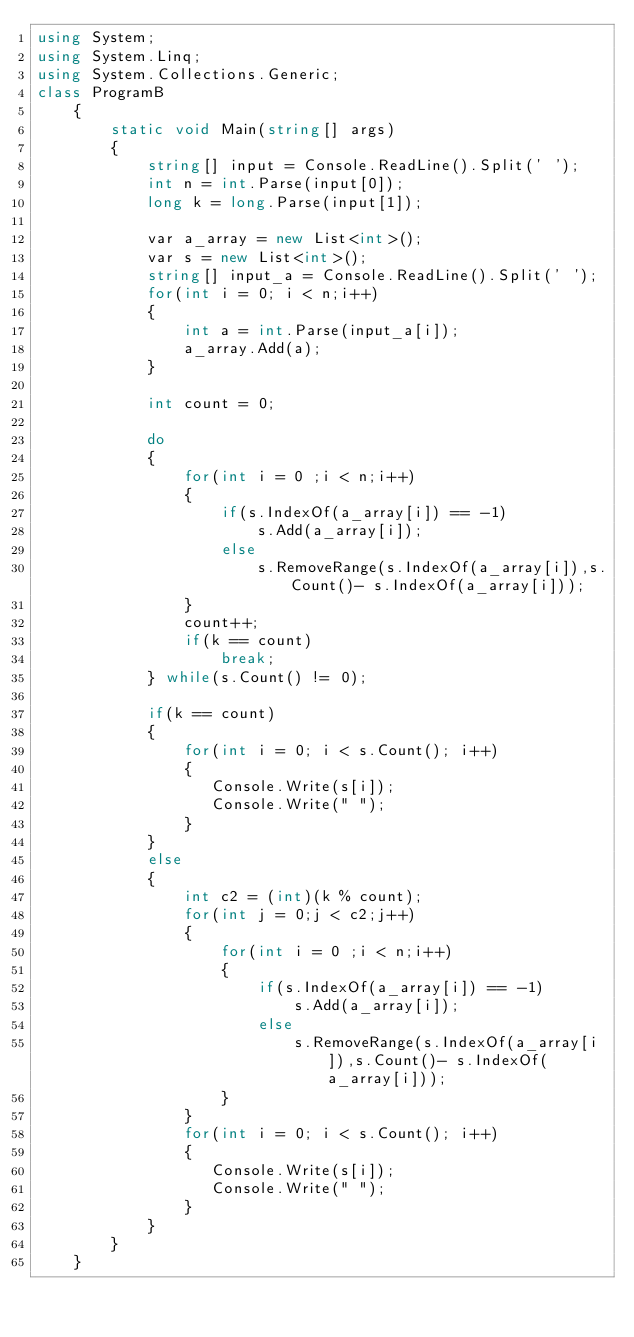Convert code to text. <code><loc_0><loc_0><loc_500><loc_500><_C#_>using System;
using System.Linq;
using System.Collections.Generic;
class ProgramB
    {
        static void Main(string[] args)
        {
            string[] input = Console.ReadLine().Split(' ');
            int n = int.Parse(input[0]);
            long k = long.Parse(input[1]);

            var a_array = new List<int>();
            var s = new List<int>();
            string[] input_a = Console.ReadLine().Split(' ');
            for(int i = 0; i < n;i++)
            {
                int a = int.Parse(input_a[i]);
                a_array.Add(a);
            }

            int count = 0;

            do
            {
                for(int i = 0 ;i < n;i++)
                {
                    if(s.IndexOf(a_array[i]) == -1)
                        s.Add(a_array[i]);
                    else
                        s.RemoveRange(s.IndexOf(a_array[i]),s.Count()- s.IndexOf(a_array[i]));
                }
                count++;
                if(k == count)
                    break;
            } while(s.Count() != 0);

            if(k == count)
            {
                for(int i = 0; i < s.Count(); i++)
                {
                   Console.Write(s[i]);
                   Console.Write(" ");
                }
            }
            else
            {
                int c2 = (int)(k % count);
                for(int j = 0;j < c2;j++)
                {
                    for(int i = 0 ;i < n;i++)
                    {
                        if(s.IndexOf(a_array[i]) == -1)
                            s.Add(a_array[i]);
                        else
                            s.RemoveRange(s.IndexOf(a_array[i]),s.Count()- s.IndexOf(a_array[i]));
                    }
                }
                for(int i = 0; i < s.Count(); i++)
                {
                   Console.Write(s[i]);
                   Console.Write(" ");
                }
            }
        }
    }</code> 